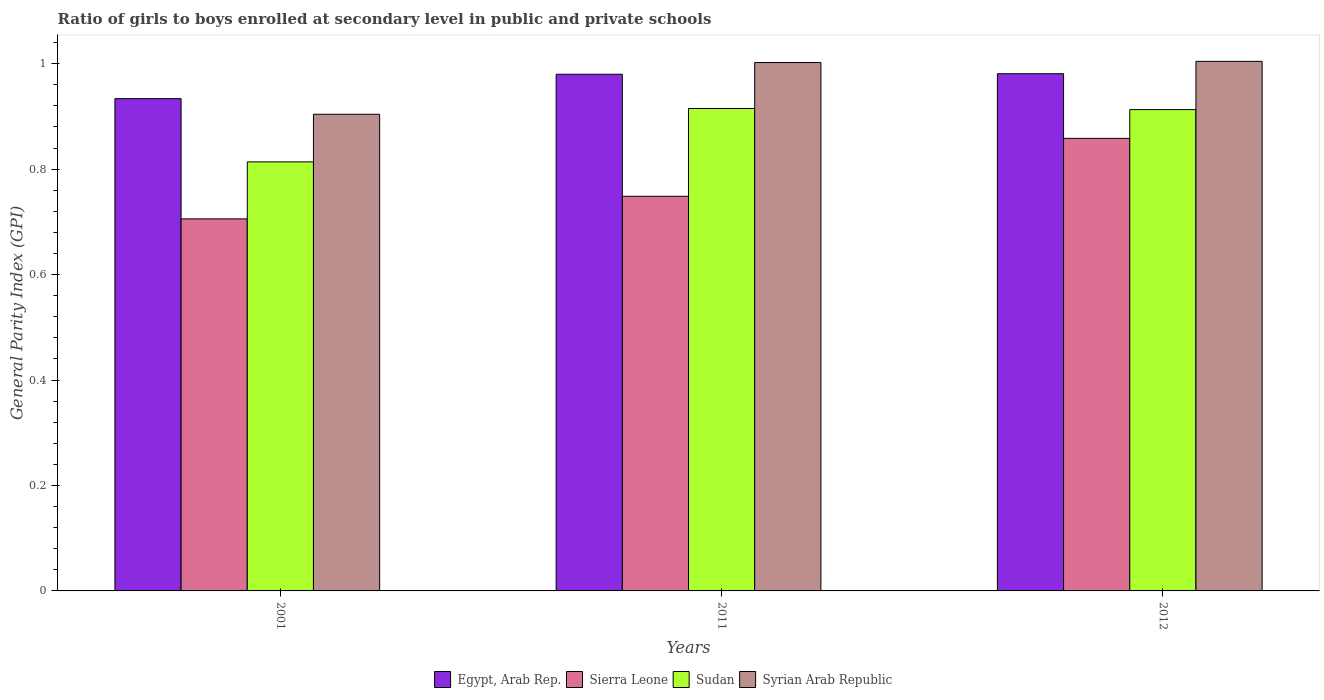How many groups of bars are there?
Your answer should be very brief. 3. Are the number of bars per tick equal to the number of legend labels?
Keep it short and to the point. Yes. Are the number of bars on each tick of the X-axis equal?
Provide a succinct answer. Yes. What is the general parity index in Sierra Leone in 2012?
Ensure brevity in your answer.  0.86. Across all years, what is the maximum general parity index in Syrian Arab Republic?
Provide a succinct answer. 1. Across all years, what is the minimum general parity index in Sierra Leone?
Make the answer very short. 0.71. In which year was the general parity index in Sierra Leone maximum?
Your answer should be compact. 2012. In which year was the general parity index in Sudan minimum?
Keep it short and to the point. 2001. What is the total general parity index in Syrian Arab Republic in the graph?
Your answer should be very brief. 2.91. What is the difference between the general parity index in Syrian Arab Republic in 2001 and that in 2011?
Offer a very short reply. -0.1. What is the difference between the general parity index in Syrian Arab Republic in 2011 and the general parity index in Egypt, Arab Rep. in 2001?
Your response must be concise. 0.07. What is the average general parity index in Sierra Leone per year?
Provide a short and direct response. 0.77. In the year 2012, what is the difference between the general parity index in Sudan and general parity index in Sierra Leone?
Ensure brevity in your answer.  0.05. In how many years, is the general parity index in Sierra Leone greater than 0.7600000000000001?
Provide a short and direct response. 1. What is the ratio of the general parity index in Sudan in 2001 to that in 2012?
Ensure brevity in your answer.  0.89. What is the difference between the highest and the second highest general parity index in Sudan?
Provide a succinct answer. 0. What is the difference between the highest and the lowest general parity index in Syrian Arab Republic?
Offer a terse response. 0.1. What does the 1st bar from the left in 2011 represents?
Make the answer very short. Egypt, Arab Rep. What does the 1st bar from the right in 2012 represents?
Provide a succinct answer. Syrian Arab Republic. Is it the case that in every year, the sum of the general parity index in Egypt, Arab Rep. and general parity index in Syrian Arab Republic is greater than the general parity index in Sudan?
Make the answer very short. Yes. How many bars are there?
Offer a terse response. 12. How many years are there in the graph?
Give a very brief answer. 3. Does the graph contain any zero values?
Keep it short and to the point. No. What is the title of the graph?
Offer a very short reply. Ratio of girls to boys enrolled at secondary level in public and private schools. Does "Somalia" appear as one of the legend labels in the graph?
Provide a succinct answer. No. What is the label or title of the Y-axis?
Keep it short and to the point. General Parity Index (GPI). What is the General Parity Index (GPI) in Egypt, Arab Rep. in 2001?
Give a very brief answer. 0.93. What is the General Parity Index (GPI) in Sierra Leone in 2001?
Offer a very short reply. 0.71. What is the General Parity Index (GPI) in Sudan in 2001?
Provide a short and direct response. 0.81. What is the General Parity Index (GPI) in Syrian Arab Republic in 2001?
Provide a succinct answer. 0.9. What is the General Parity Index (GPI) of Egypt, Arab Rep. in 2011?
Your answer should be very brief. 0.98. What is the General Parity Index (GPI) of Sierra Leone in 2011?
Keep it short and to the point. 0.75. What is the General Parity Index (GPI) of Sudan in 2011?
Your response must be concise. 0.92. What is the General Parity Index (GPI) of Syrian Arab Republic in 2011?
Your response must be concise. 1. What is the General Parity Index (GPI) in Egypt, Arab Rep. in 2012?
Give a very brief answer. 0.98. What is the General Parity Index (GPI) in Sierra Leone in 2012?
Offer a very short reply. 0.86. What is the General Parity Index (GPI) of Sudan in 2012?
Provide a succinct answer. 0.91. What is the General Parity Index (GPI) in Syrian Arab Republic in 2012?
Offer a terse response. 1. Across all years, what is the maximum General Parity Index (GPI) in Egypt, Arab Rep.?
Your answer should be compact. 0.98. Across all years, what is the maximum General Parity Index (GPI) in Sierra Leone?
Provide a short and direct response. 0.86. Across all years, what is the maximum General Parity Index (GPI) in Sudan?
Your answer should be very brief. 0.92. Across all years, what is the maximum General Parity Index (GPI) of Syrian Arab Republic?
Provide a succinct answer. 1. Across all years, what is the minimum General Parity Index (GPI) of Egypt, Arab Rep.?
Your answer should be very brief. 0.93. Across all years, what is the minimum General Parity Index (GPI) in Sierra Leone?
Your response must be concise. 0.71. Across all years, what is the minimum General Parity Index (GPI) in Sudan?
Your answer should be compact. 0.81. Across all years, what is the minimum General Parity Index (GPI) of Syrian Arab Republic?
Make the answer very short. 0.9. What is the total General Parity Index (GPI) in Egypt, Arab Rep. in the graph?
Ensure brevity in your answer.  2.89. What is the total General Parity Index (GPI) in Sierra Leone in the graph?
Offer a very short reply. 2.31. What is the total General Parity Index (GPI) in Sudan in the graph?
Your answer should be compact. 2.64. What is the total General Parity Index (GPI) of Syrian Arab Republic in the graph?
Ensure brevity in your answer.  2.91. What is the difference between the General Parity Index (GPI) of Egypt, Arab Rep. in 2001 and that in 2011?
Offer a very short reply. -0.05. What is the difference between the General Parity Index (GPI) in Sierra Leone in 2001 and that in 2011?
Provide a short and direct response. -0.04. What is the difference between the General Parity Index (GPI) of Sudan in 2001 and that in 2011?
Your answer should be compact. -0.1. What is the difference between the General Parity Index (GPI) in Syrian Arab Republic in 2001 and that in 2011?
Make the answer very short. -0.1. What is the difference between the General Parity Index (GPI) of Egypt, Arab Rep. in 2001 and that in 2012?
Make the answer very short. -0.05. What is the difference between the General Parity Index (GPI) of Sierra Leone in 2001 and that in 2012?
Provide a short and direct response. -0.15. What is the difference between the General Parity Index (GPI) of Sudan in 2001 and that in 2012?
Your response must be concise. -0.1. What is the difference between the General Parity Index (GPI) in Syrian Arab Republic in 2001 and that in 2012?
Offer a terse response. -0.1. What is the difference between the General Parity Index (GPI) of Egypt, Arab Rep. in 2011 and that in 2012?
Ensure brevity in your answer.  -0. What is the difference between the General Parity Index (GPI) of Sierra Leone in 2011 and that in 2012?
Provide a succinct answer. -0.11. What is the difference between the General Parity Index (GPI) in Sudan in 2011 and that in 2012?
Your answer should be compact. 0. What is the difference between the General Parity Index (GPI) in Syrian Arab Republic in 2011 and that in 2012?
Provide a succinct answer. -0. What is the difference between the General Parity Index (GPI) of Egypt, Arab Rep. in 2001 and the General Parity Index (GPI) of Sierra Leone in 2011?
Your response must be concise. 0.19. What is the difference between the General Parity Index (GPI) in Egypt, Arab Rep. in 2001 and the General Parity Index (GPI) in Sudan in 2011?
Provide a short and direct response. 0.02. What is the difference between the General Parity Index (GPI) in Egypt, Arab Rep. in 2001 and the General Parity Index (GPI) in Syrian Arab Republic in 2011?
Provide a short and direct response. -0.07. What is the difference between the General Parity Index (GPI) in Sierra Leone in 2001 and the General Parity Index (GPI) in Sudan in 2011?
Offer a terse response. -0.21. What is the difference between the General Parity Index (GPI) of Sierra Leone in 2001 and the General Parity Index (GPI) of Syrian Arab Republic in 2011?
Your answer should be compact. -0.3. What is the difference between the General Parity Index (GPI) of Sudan in 2001 and the General Parity Index (GPI) of Syrian Arab Republic in 2011?
Offer a very short reply. -0.19. What is the difference between the General Parity Index (GPI) in Egypt, Arab Rep. in 2001 and the General Parity Index (GPI) in Sierra Leone in 2012?
Keep it short and to the point. 0.08. What is the difference between the General Parity Index (GPI) in Egypt, Arab Rep. in 2001 and the General Parity Index (GPI) in Sudan in 2012?
Provide a short and direct response. 0.02. What is the difference between the General Parity Index (GPI) in Egypt, Arab Rep. in 2001 and the General Parity Index (GPI) in Syrian Arab Republic in 2012?
Provide a short and direct response. -0.07. What is the difference between the General Parity Index (GPI) in Sierra Leone in 2001 and the General Parity Index (GPI) in Sudan in 2012?
Keep it short and to the point. -0.21. What is the difference between the General Parity Index (GPI) of Sierra Leone in 2001 and the General Parity Index (GPI) of Syrian Arab Republic in 2012?
Keep it short and to the point. -0.3. What is the difference between the General Parity Index (GPI) of Sudan in 2001 and the General Parity Index (GPI) of Syrian Arab Republic in 2012?
Provide a short and direct response. -0.19. What is the difference between the General Parity Index (GPI) of Egypt, Arab Rep. in 2011 and the General Parity Index (GPI) of Sierra Leone in 2012?
Your answer should be very brief. 0.12. What is the difference between the General Parity Index (GPI) in Egypt, Arab Rep. in 2011 and the General Parity Index (GPI) in Sudan in 2012?
Make the answer very short. 0.07. What is the difference between the General Parity Index (GPI) in Egypt, Arab Rep. in 2011 and the General Parity Index (GPI) in Syrian Arab Republic in 2012?
Your answer should be compact. -0.02. What is the difference between the General Parity Index (GPI) in Sierra Leone in 2011 and the General Parity Index (GPI) in Sudan in 2012?
Your answer should be very brief. -0.16. What is the difference between the General Parity Index (GPI) of Sierra Leone in 2011 and the General Parity Index (GPI) of Syrian Arab Republic in 2012?
Offer a terse response. -0.26. What is the difference between the General Parity Index (GPI) in Sudan in 2011 and the General Parity Index (GPI) in Syrian Arab Republic in 2012?
Ensure brevity in your answer.  -0.09. What is the average General Parity Index (GPI) of Egypt, Arab Rep. per year?
Give a very brief answer. 0.96. What is the average General Parity Index (GPI) of Sierra Leone per year?
Offer a terse response. 0.77. What is the average General Parity Index (GPI) in Sudan per year?
Keep it short and to the point. 0.88. What is the average General Parity Index (GPI) in Syrian Arab Republic per year?
Offer a very short reply. 0.97. In the year 2001, what is the difference between the General Parity Index (GPI) of Egypt, Arab Rep. and General Parity Index (GPI) of Sierra Leone?
Offer a terse response. 0.23. In the year 2001, what is the difference between the General Parity Index (GPI) in Egypt, Arab Rep. and General Parity Index (GPI) in Sudan?
Give a very brief answer. 0.12. In the year 2001, what is the difference between the General Parity Index (GPI) of Egypt, Arab Rep. and General Parity Index (GPI) of Syrian Arab Republic?
Your response must be concise. 0.03. In the year 2001, what is the difference between the General Parity Index (GPI) in Sierra Leone and General Parity Index (GPI) in Sudan?
Your answer should be very brief. -0.11. In the year 2001, what is the difference between the General Parity Index (GPI) in Sierra Leone and General Parity Index (GPI) in Syrian Arab Republic?
Your answer should be compact. -0.2. In the year 2001, what is the difference between the General Parity Index (GPI) of Sudan and General Parity Index (GPI) of Syrian Arab Republic?
Your answer should be very brief. -0.09. In the year 2011, what is the difference between the General Parity Index (GPI) of Egypt, Arab Rep. and General Parity Index (GPI) of Sierra Leone?
Make the answer very short. 0.23. In the year 2011, what is the difference between the General Parity Index (GPI) of Egypt, Arab Rep. and General Parity Index (GPI) of Sudan?
Give a very brief answer. 0.06. In the year 2011, what is the difference between the General Parity Index (GPI) of Egypt, Arab Rep. and General Parity Index (GPI) of Syrian Arab Republic?
Make the answer very short. -0.02. In the year 2011, what is the difference between the General Parity Index (GPI) in Sierra Leone and General Parity Index (GPI) in Sudan?
Give a very brief answer. -0.17. In the year 2011, what is the difference between the General Parity Index (GPI) of Sierra Leone and General Parity Index (GPI) of Syrian Arab Republic?
Provide a succinct answer. -0.25. In the year 2011, what is the difference between the General Parity Index (GPI) of Sudan and General Parity Index (GPI) of Syrian Arab Republic?
Ensure brevity in your answer.  -0.09. In the year 2012, what is the difference between the General Parity Index (GPI) in Egypt, Arab Rep. and General Parity Index (GPI) in Sierra Leone?
Your answer should be very brief. 0.12. In the year 2012, what is the difference between the General Parity Index (GPI) in Egypt, Arab Rep. and General Parity Index (GPI) in Sudan?
Your answer should be compact. 0.07. In the year 2012, what is the difference between the General Parity Index (GPI) in Egypt, Arab Rep. and General Parity Index (GPI) in Syrian Arab Republic?
Offer a very short reply. -0.02. In the year 2012, what is the difference between the General Parity Index (GPI) of Sierra Leone and General Parity Index (GPI) of Sudan?
Provide a short and direct response. -0.05. In the year 2012, what is the difference between the General Parity Index (GPI) in Sierra Leone and General Parity Index (GPI) in Syrian Arab Republic?
Provide a succinct answer. -0.15. In the year 2012, what is the difference between the General Parity Index (GPI) of Sudan and General Parity Index (GPI) of Syrian Arab Republic?
Make the answer very short. -0.09. What is the ratio of the General Parity Index (GPI) in Egypt, Arab Rep. in 2001 to that in 2011?
Provide a succinct answer. 0.95. What is the ratio of the General Parity Index (GPI) in Sierra Leone in 2001 to that in 2011?
Your answer should be compact. 0.94. What is the ratio of the General Parity Index (GPI) of Sudan in 2001 to that in 2011?
Offer a very short reply. 0.89. What is the ratio of the General Parity Index (GPI) in Syrian Arab Republic in 2001 to that in 2011?
Make the answer very short. 0.9. What is the ratio of the General Parity Index (GPI) in Egypt, Arab Rep. in 2001 to that in 2012?
Your response must be concise. 0.95. What is the ratio of the General Parity Index (GPI) of Sierra Leone in 2001 to that in 2012?
Offer a terse response. 0.82. What is the ratio of the General Parity Index (GPI) of Sudan in 2001 to that in 2012?
Your answer should be compact. 0.89. What is the ratio of the General Parity Index (GPI) of Syrian Arab Republic in 2001 to that in 2012?
Offer a terse response. 0.9. What is the ratio of the General Parity Index (GPI) of Sierra Leone in 2011 to that in 2012?
Provide a succinct answer. 0.87. What is the ratio of the General Parity Index (GPI) in Sudan in 2011 to that in 2012?
Your answer should be compact. 1. What is the ratio of the General Parity Index (GPI) of Syrian Arab Republic in 2011 to that in 2012?
Provide a succinct answer. 1. What is the difference between the highest and the second highest General Parity Index (GPI) in Egypt, Arab Rep.?
Provide a succinct answer. 0. What is the difference between the highest and the second highest General Parity Index (GPI) of Sierra Leone?
Keep it short and to the point. 0.11. What is the difference between the highest and the second highest General Parity Index (GPI) of Sudan?
Provide a succinct answer. 0. What is the difference between the highest and the second highest General Parity Index (GPI) of Syrian Arab Republic?
Your answer should be very brief. 0. What is the difference between the highest and the lowest General Parity Index (GPI) in Egypt, Arab Rep.?
Offer a terse response. 0.05. What is the difference between the highest and the lowest General Parity Index (GPI) of Sierra Leone?
Offer a very short reply. 0.15. What is the difference between the highest and the lowest General Parity Index (GPI) in Sudan?
Give a very brief answer. 0.1. What is the difference between the highest and the lowest General Parity Index (GPI) in Syrian Arab Republic?
Offer a terse response. 0.1. 